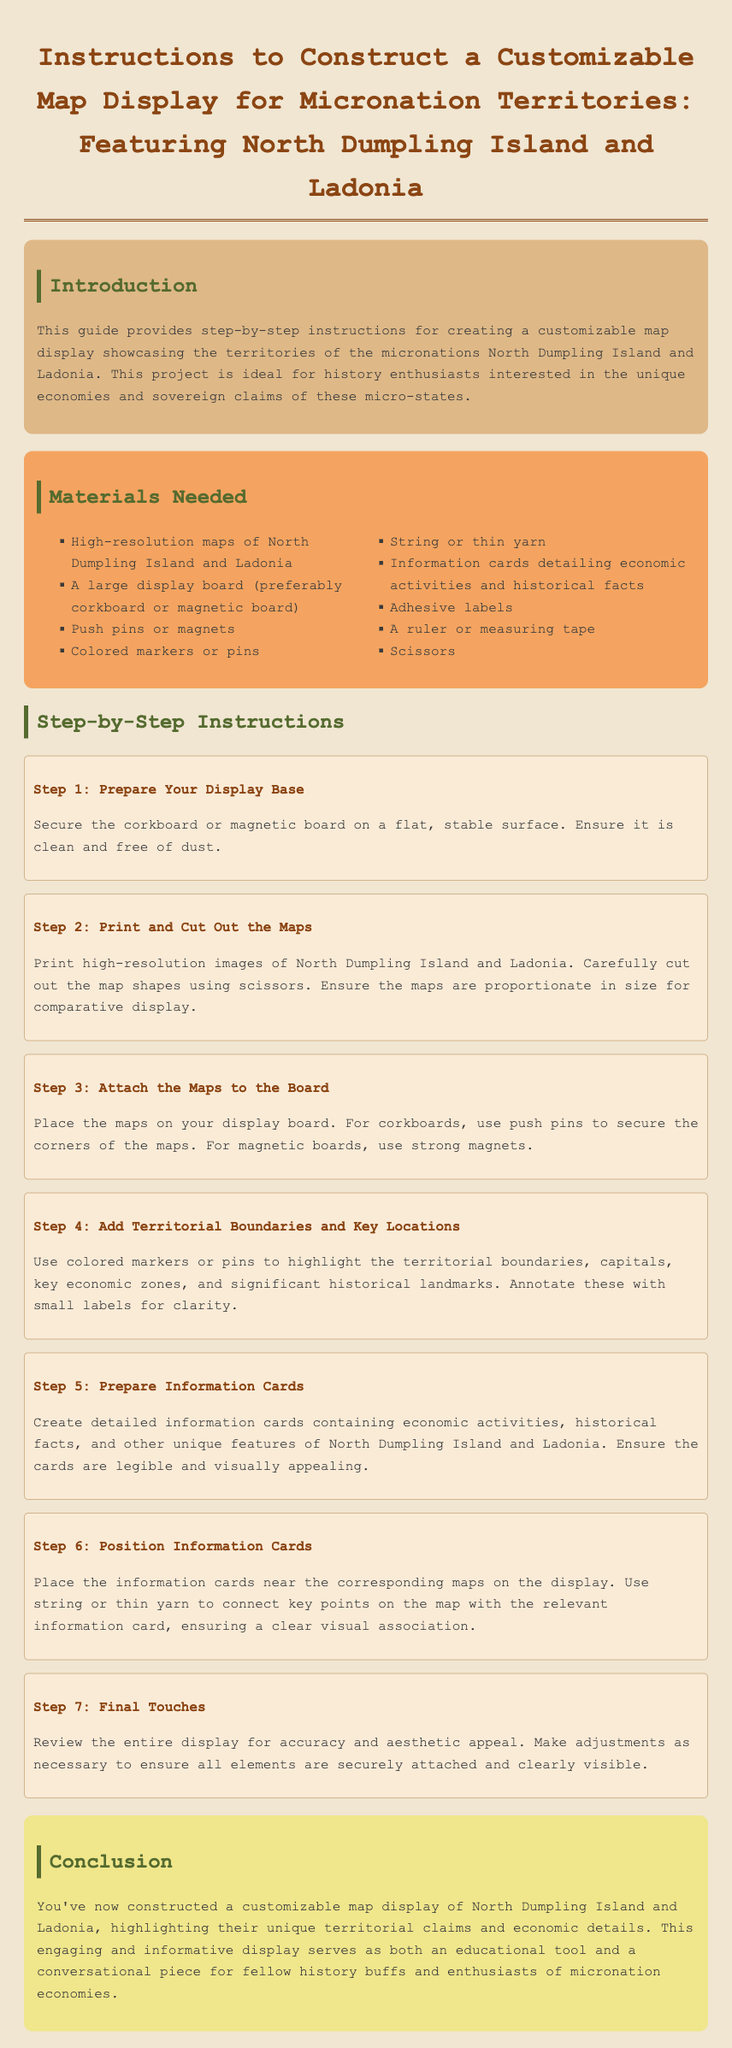What is the title of the document? The title is the main heading at the top of the document, which describes the instructions for a map display.
Answer: Instructions to Construct a Customizable Map Display for Micronation Territories: Featuring North Dumpling Island and Ladonia How many steps are in the instructions? The step-by-step instructions section is composed of multiple discrete steps, specifically listed for clarity.
Answer: 7 What type of board is recommended for the display? The materials section specifies the type of display board ideal for this project.
Answer: Corkboard or magnetic board What should the information cards contain? The instructions detail what information to include on the information cards next to the maps for added educational value.
Answer: Economic activities and historical facts What is the main focus of the customizable map display? The introduction section outlines the primary subjects that the map display will showcase.
Answer: Territories of North Dumpling Island and Ladonia What color are the headings in the document? The document describes the stylings used, including the colors used for different headings.
Answer: Brown and green Which sewing item is listed among the materials? The materials section lists various items needed, including any that relate to sewing or crafting.
Answer: String or thin yarn 